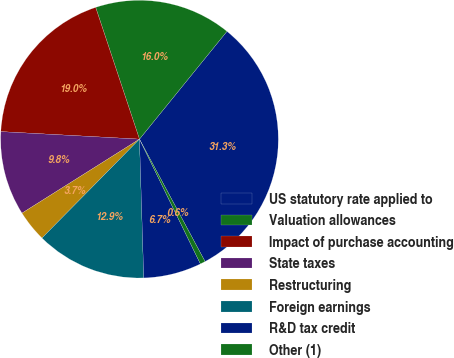Convert chart to OTSL. <chart><loc_0><loc_0><loc_500><loc_500><pie_chart><fcel>US statutory rate applied to<fcel>Valuation allowances<fcel>Impact of purchase accounting<fcel>State taxes<fcel>Restructuring<fcel>Foreign earnings<fcel>R&D tax credit<fcel>Other (1)<nl><fcel>31.32%<fcel>15.96%<fcel>19.03%<fcel>9.81%<fcel>3.67%<fcel>12.88%<fcel>6.74%<fcel>0.6%<nl></chart> 